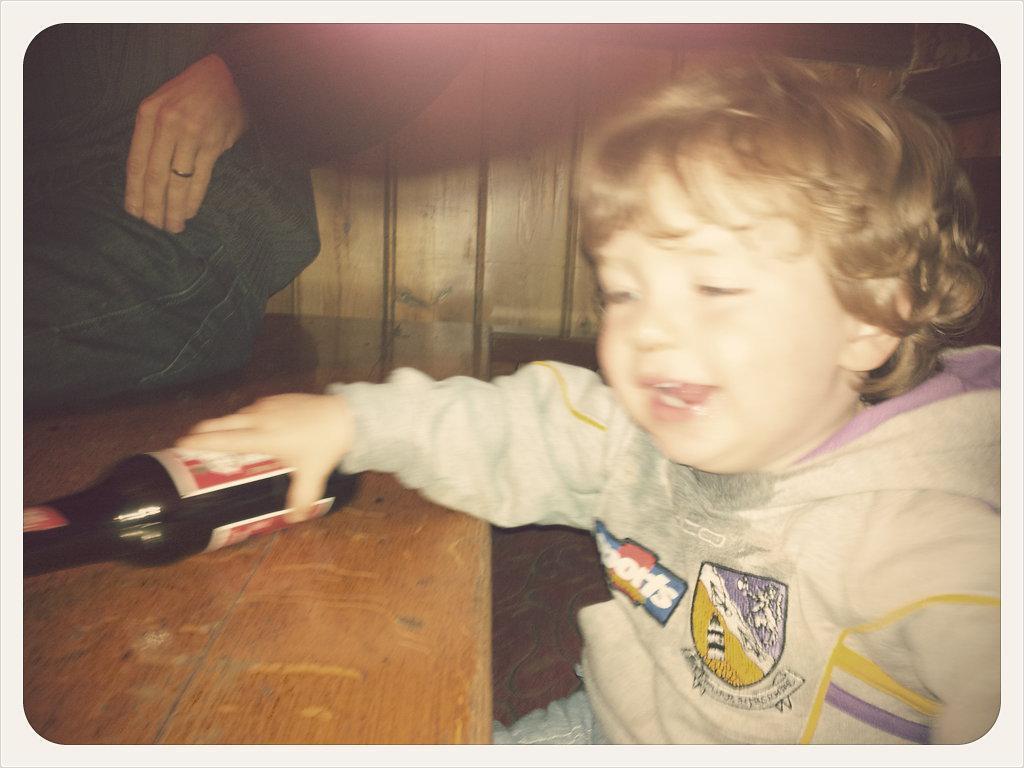Describe this image in one or two sentences. A boy wearing a white dress is holding a bottle. And bottle is on the table. And a person is sitting on the table. 